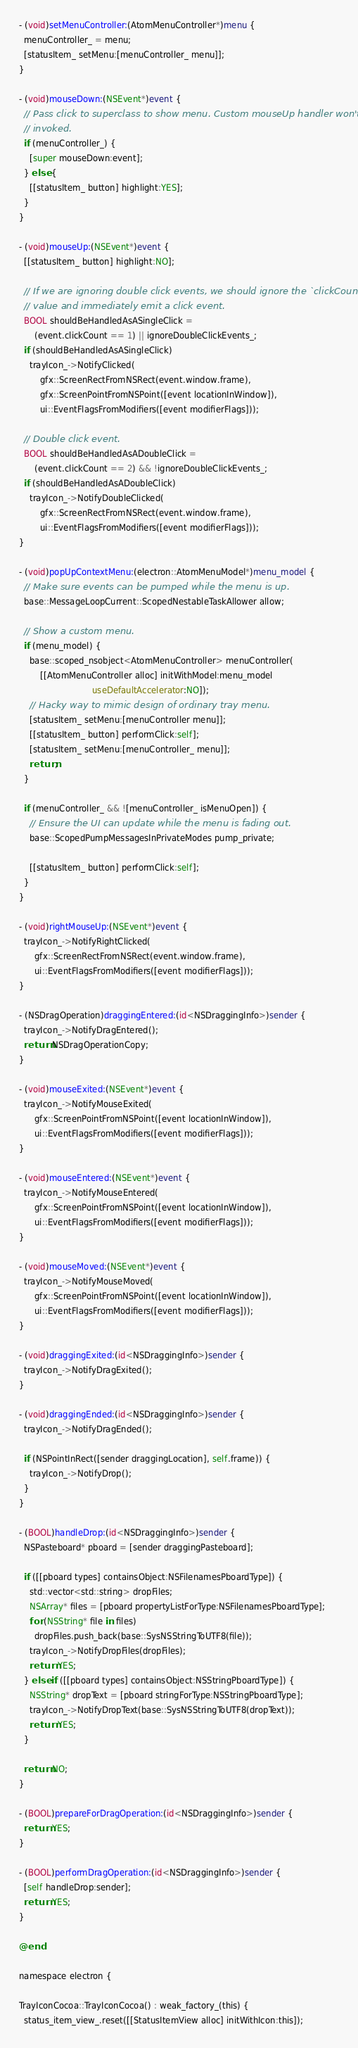<code> <loc_0><loc_0><loc_500><loc_500><_ObjectiveC_>
- (void)setMenuController:(AtomMenuController*)menu {
  menuController_ = menu;
  [statusItem_ setMenu:[menuController_ menu]];
}

- (void)mouseDown:(NSEvent*)event {
  // Pass click to superclass to show menu. Custom mouseUp handler won't be
  // invoked.
  if (menuController_) {
    [super mouseDown:event];
  } else {
    [[statusItem_ button] highlight:YES];
  }
}

- (void)mouseUp:(NSEvent*)event {
  [[statusItem_ button] highlight:NO];

  // If we are ignoring double click events, we should ignore the `clickCount`
  // value and immediately emit a click event.
  BOOL shouldBeHandledAsASingleClick =
      (event.clickCount == 1) || ignoreDoubleClickEvents_;
  if (shouldBeHandledAsASingleClick)
    trayIcon_->NotifyClicked(
        gfx::ScreenRectFromNSRect(event.window.frame),
        gfx::ScreenPointFromNSPoint([event locationInWindow]),
        ui::EventFlagsFromModifiers([event modifierFlags]));

  // Double click event.
  BOOL shouldBeHandledAsADoubleClick =
      (event.clickCount == 2) && !ignoreDoubleClickEvents_;
  if (shouldBeHandledAsADoubleClick)
    trayIcon_->NotifyDoubleClicked(
        gfx::ScreenRectFromNSRect(event.window.frame),
        ui::EventFlagsFromModifiers([event modifierFlags]));
}

- (void)popUpContextMenu:(electron::AtomMenuModel*)menu_model {
  // Make sure events can be pumped while the menu is up.
  base::MessageLoopCurrent::ScopedNestableTaskAllower allow;

  // Show a custom menu.
  if (menu_model) {
    base::scoped_nsobject<AtomMenuController> menuController(
        [[AtomMenuController alloc] initWithModel:menu_model
                            useDefaultAccelerator:NO]);
    // Hacky way to mimic design of ordinary tray menu.
    [statusItem_ setMenu:[menuController menu]];
    [[statusItem_ button] performClick:self];
    [statusItem_ setMenu:[menuController_ menu]];
    return;
  }

  if (menuController_ && ![menuController_ isMenuOpen]) {
    // Ensure the UI can update while the menu is fading out.
    base::ScopedPumpMessagesInPrivateModes pump_private;

    [[statusItem_ button] performClick:self];
  }
}

- (void)rightMouseUp:(NSEvent*)event {
  trayIcon_->NotifyRightClicked(
      gfx::ScreenRectFromNSRect(event.window.frame),
      ui::EventFlagsFromModifiers([event modifierFlags]));
}

- (NSDragOperation)draggingEntered:(id<NSDraggingInfo>)sender {
  trayIcon_->NotifyDragEntered();
  return NSDragOperationCopy;
}

- (void)mouseExited:(NSEvent*)event {
  trayIcon_->NotifyMouseExited(
      gfx::ScreenPointFromNSPoint([event locationInWindow]),
      ui::EventFlagsFromModifiers([event modifierFlags]));
}

- (void)mouseEntered:(NSEvent*)event {
  trayIcon_->NotifyMouseEntered(
      gfx::ScreenPointFromNSPoint([event locationInWindow]),
      ui::EventFlagsFromModifiers([event modifierFlags]));
}

- (void)mouseMoved:(NSEvent*)event {
  trayIcon_->NotifyMouseMoved(
      gfx::ScreenPointFromNSPoint([event locationInWindow]),
      ui::EventFlagsFromModifiers([event modifierFlags]));
}

- (void)draggingExited:(id<NSDraggingInfo>)sender {
  trayIcon_->NotifyDragExited();
}

- (void)draggingEnded:(id<NSDraggingInfo>)sender {
  trayIcon_->NotifyDragEnded();

  if (NSPointInRect([sender draggingLocation], self.frame)) {
    trayIcon_->NotifyDrop();
  }
}

- (BOOL)handleDrop:(id<NSDraggingInfo>)sender {
  NSPasteboard* pboard = [sender draggingPasteboard];

  if ([[pboard types] containsObject:NSFilenamesPboardType]) {
    std::vector<std::string> dropFiles;
    NSArray* files = [pboard propertyListForType:NSFilenamesPboardType];
    for (NSString* file in files)
      dropFiles.push_back(base::SysNSStringToUTF8(file));
    trayIcon_->NotifyDropFiles(dropFiles);
    return YES;
  } else if ([[pboard types] containsObject:NSStringPboardType]) {
    NSString* dropText = [pboard stringForType:NSStringPboardType];
    trayIcon_->NotifyDropText(base::SysNSStringToUTF8(dropText));
    return YES;
  }

  return NO;
}

- (BOOL)prepareForDragOperation:(id<NSDraggingInfo>)sender {
  return YES;
}

- (BOOL)performDragOperation:(id<NSDraggingInfo>)sender {
  [self handleDrop:sender];
  return YES;
}

@end

namespace electron {

TrayIconCocoa::TrayIconCocoa() : weak_factory_(this) {
  status_item_view_.reset([[StatusItemView alloc] initWithIcon:this]);</code> 